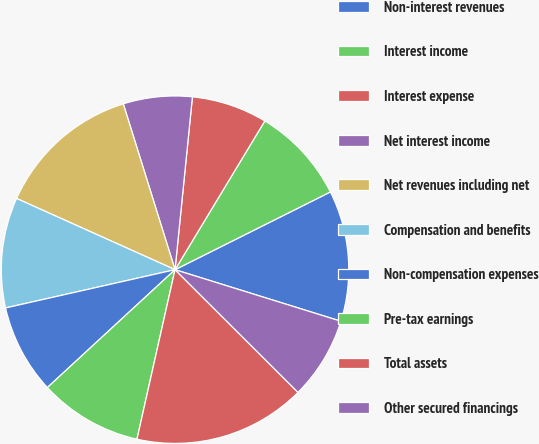<chart> <loc_0><loc_0><loc_500><loc_500><pie_chart><fcel>Non-interest revenues<fcel>Interest income<fcel>Interest expense<fcel>Net interest income<fcel>Net revenues including net<fcel>Compensation and benefits<fcel>Non-compensation expenses<fcel>Pre-tax earnings<fcel>Total assets<fcel>Other secured financings<nl><fcel>12.18%<fcel>8.97%<fcel>7.05%<fcel>6.41%<fcel>13.46%<fcel>10.26%<fcel>8.33%<fcel>9.62%<fcel>16.03%<fcel>7.69%<nl></chart> 